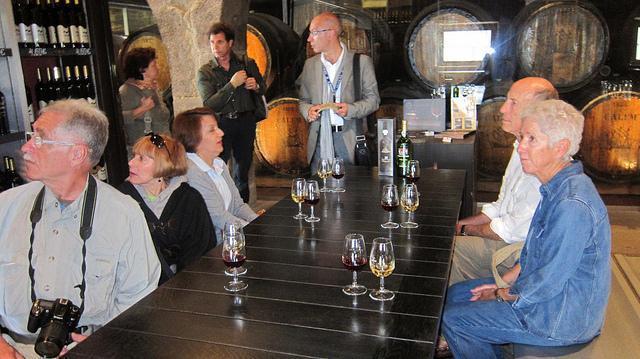How many people are wearing glasses?
Give a very brief answer. 2. How many people are in the picture?
Give a very brief answer. 8. How many baby elephants are there?
Give a very brief answer. 0. 